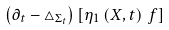<formula> <loc_0><loc_0><loc_500><loc_500>\left ( \partial _ { t } - \triangle _ { \Sigma _ { t } } \right ) \left [ \eta _ { 1 } \left ( X , t \right ) \, f \right ]</formula> 